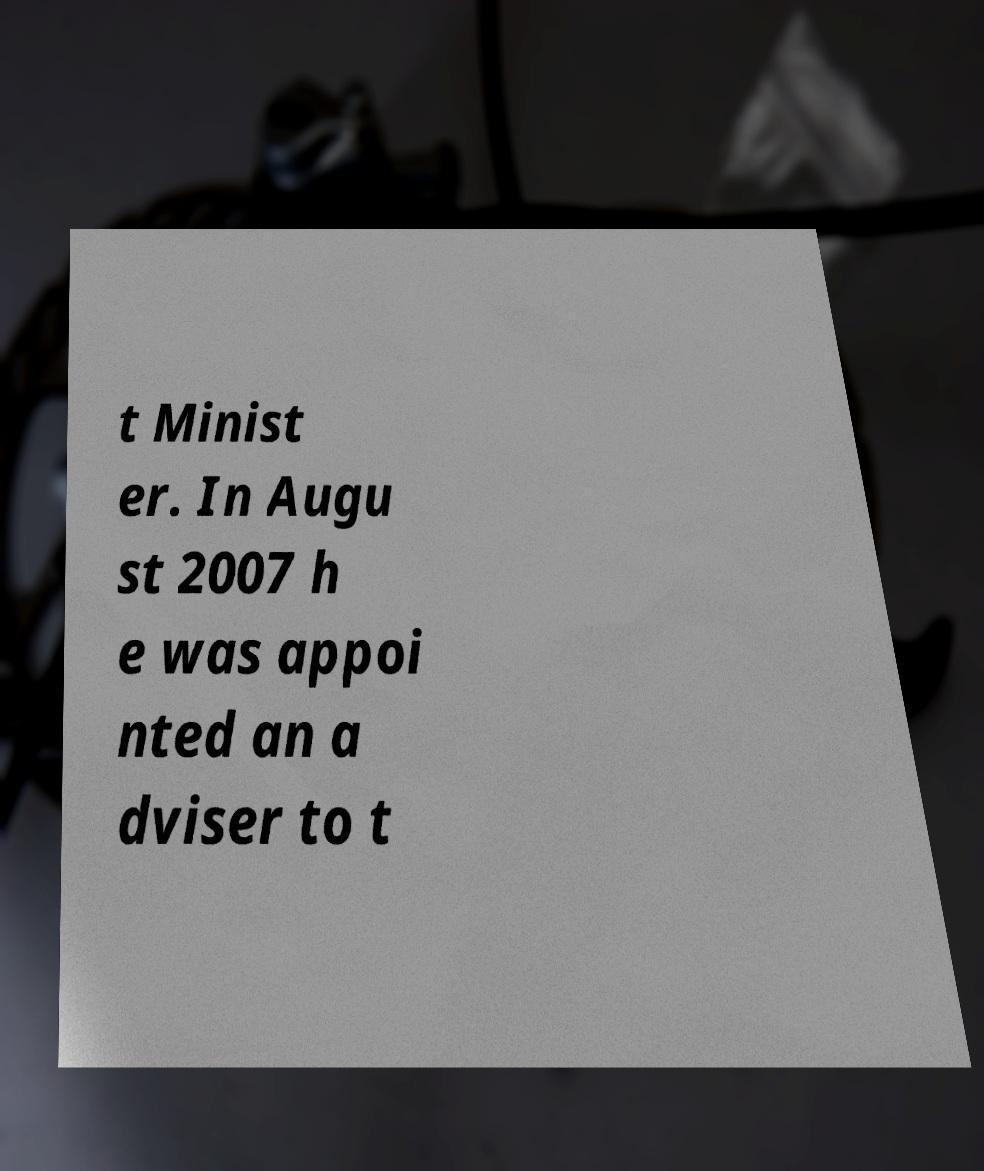I need the written content from this picture converted into text. Can you do that? t Minist er. In Augu st 2007 h e was appoi nted an a dviser to t 